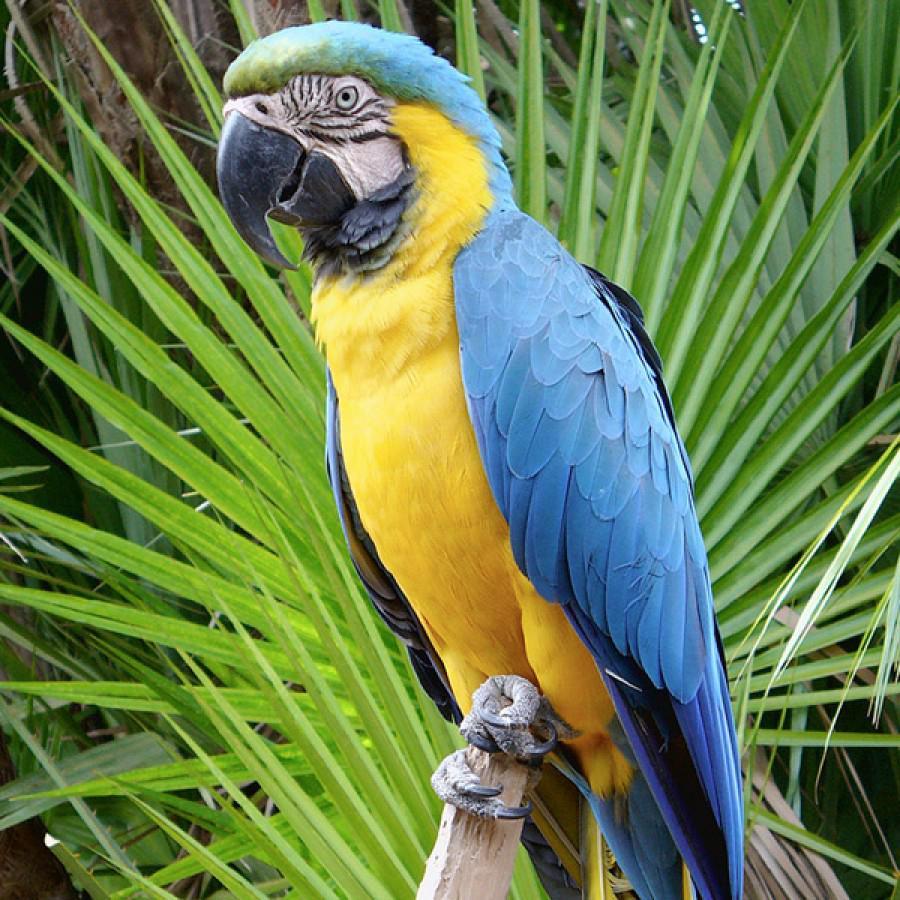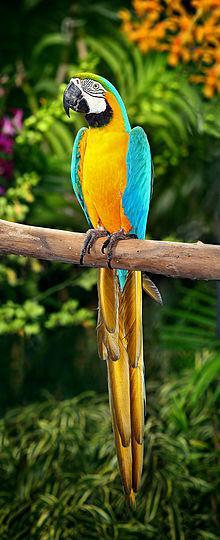The first image is the image on the left, the second image is the image on the right. Examine the images to the left and right. Is the description "All birds shown have blue and yellow coloring, and at least one image has green fanning fronds in the background." accurate? Answer yes or no. Yes. The first image is the image on the left, the second image is the image on the right. For the images shown, is this caption "There are two birds, each perched on a branch." true? Answer yes or no. Yes. The first image is the image on the left, the second image is the image on the right. Considering the images on both sides, is "There are at least two parrots in the right image." valid? Answer yes or no. No. The first image is the image on the left, the second image is the image on the right. For the images displayed, is the sentence "There are two blue and yellow birds" factually correct? Answer yes or no. Yes. 